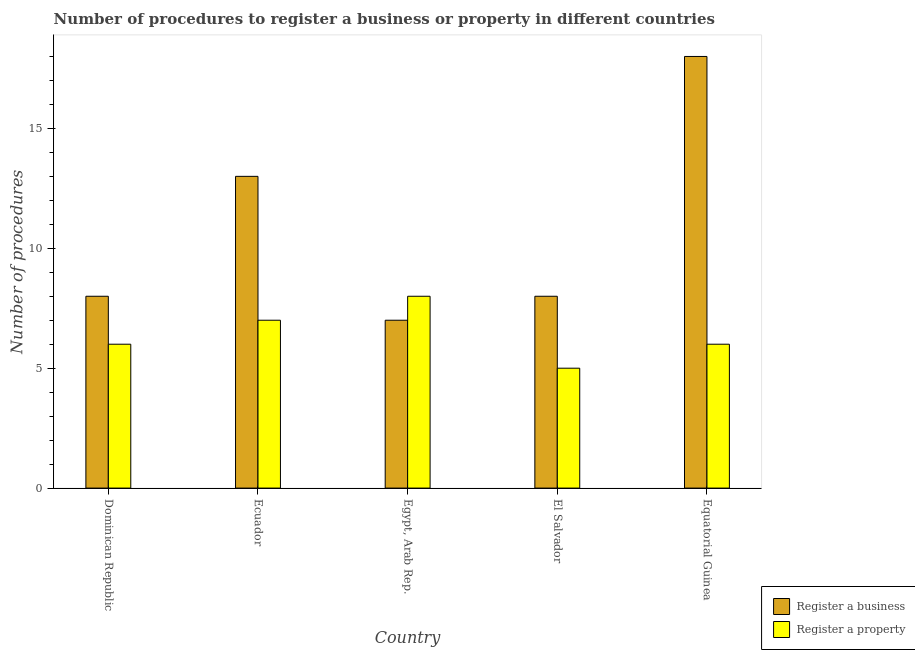How many different coloured bars are there?
Offer a very short reply. 2. How many bars are there on the 4th tick from the left?
Offer a very short reply. 2. What is the label of the 5th group of bars from the left?
Provide a short and direct response. Equatorial Guinea. What is the number of procedures to register a property in Equatorial Guinea?
Provide a short and direct response. 6. In which country was the number of procedures to register a property maximum?
Keep it short and to the point. Egypt, Arab Rep. In which country was the number of procedures to register a business minimum?
Provide a succinct answer. Egypt, Arab Rep. What is the total number of procedures to register a business in the graph?
Provide a succinct answer. 54. What is the difference between the number of procedures to register a business in Dominican Republic and that in Egypt, Arab Rep.?
Offer a very short reply. 1. What is the average number of procedures to register a property per country?
Ensure brevity in your answer.  6.4. What is the difference between the number of procedures to register a property and number of procedures to register a business in Dominican Republic?
Offer a terse response. -2. What is the ratio of the number of procedures to register a business in Dominican Republic to that in Ecuador?
Give a very brief answer. 0.62. Is the difference between the number of procedures to register a property in Dominican Republic and Ecuador greater than the difference between the number of procedures to register a business in Dominican Republic and Ecuador?
Your answer should be compact. Yes. What is the difference between the highest and the lowest number of procedures to register a business?
Your answer should be very brief. 11. Is the sum of the number of procedures to register a business in Dominican Republic and Equatorial Guinea greater than the maximum number of procedures to register a property across all countries?
Provide a succinct answer. Yes. What does the 1st bar from the left in Egypt, Arab Rep. represents?
Your response must be concise. Register a business. What does the 1st bar from the right in Equatorial Guinea represents?
Provide a short and direct response. Register a property. How many bars are there?
Provide a succinct answer. 10. Does the graph contain any zero values?
Provide a succinct answer. No. Does the graph contain grids?
Your answer should be compact. No. How many legend labels are there?
Your answer should be compact. 2. How are the legend labels stacked?
Offer a very short reply. Vertical. What is the title of the graph?
Provide a succinct answer. Number of procedures to register a business or property in different countries. Does "Lower secondary rate" appear as one of the legend labels in the graph?
Keep it short and to the point. No. What is the label or title of the X-axis?
Provide a succinct answer. Country. What is the label or title of the Y-axis?
Ensure brevity in your answer.  Number of procedures. What is the Number of procedures in Register a business in Ecuador?
Your response must be concise. 13. What is the Number of procedures of Register a property in Egypt, Arab Rep.?
Offer a terse response. 8. What is the Number of procedures of Register a business in El Salvador?
Your answer should be very brief. 8. What is the Number of procedures in Register a business in Equatorial Guinea?
Give a very brief answer. 18. What is the Number of procedures in Register a property in Equatorial Guinea?
Offer a very short reply. 6. Across all countries, what is the maximum Number of procedures in Register a business?
Provide a short and direct response. 18. Across all countries, what is the minimum Number of procedures in Register a property?
Your response must be concise. 5. What is the total Number of procedures in Register a business in the graph?
Your answer should be very brief. 54. What is the total Number of procedures in Register a property in the graph?
Keep it short and to the point. 32. What is the difference between the Number of procedures of Register a business in Dominican Republic and that in Ecuador?
Make the answer very short. -5. What is the difference between the Number of procedures of Register a business in Dominican Republic and that in Egypt, Arab Rep.?
Ensure brevity in your answer.  1. What is the difference between the Number of procedures of Register a property in Dominican Republic and that in Egypt, Arab Rep.?
Ensure brevity in your answer.  -2. What is the difference between the Number of procedures of Register a property in Dominican Republic and that in Equatorial Guinea?
Your response must be concise. 0. What is the difference between the Number of procedures of Register a property in Ecuador and that in Egypt, Arab Rep.?
Ensure brevity in your answer.  -1. What is the difference between the Number of procedures in Register a property in Ecuador and that in El Salvador?
Offer a terse response. 2. What is the difference between the Number of procedures of Register a property in Ecuador and that in Equatorial Guinea?
Offer a terse response. 1. What is the difference between the Number of procedures of Register a property in Egypt, Arab Rep. and that in Equatorial Guinea?
Your response must be concise. 2. What is the difference between the Number of procedures in Register a business in Dominican Republic and the Number of procedures in Register a property in Equatorial Guinea?
Keep it short and to the point. 2. What is the difference between the Number of procedures in Register a business in Ecuador and the Number of procedures in Register a property in Egypt, Arab Rep.?
Give a very brief answer. 5. What is the difference between the Number of procedures in Register a business in Ecuador and the Number of procedures in Register a property in El Salvador?
Give a very brief answer. 8. What is the difference between the Number of procedures of Register a business in Ecuador and the Number of procedures of Register a property in Equatorial Guinea?
Give a very brief answer. 7. What is the difference between the Number of procedures of Register a business in Egypt, Arab Rep. and the Number of procedures of Register a property in El Salvador?
Your answer should be very brief. 2. What is the difference between the Number of procedures of Register a business in Egypt, Arab Rep. and the Number of procedures of Register a property in Equatorial Guinea?
Ensure brevity in your answer.  1. What is the difference between the Number of procedures in Register a business in El Salvador and the Number of procedures in Register a property in Equatorial Guinea?
Offer a terse response. 2. What is the average Number of procedures of Register a property per country?
Offer a very short reply. 6.4. What is the difference between the Number of procedures of Register a business and Number of procedures of Register a property in Ecuador?
Your answer should be compact. 6. What is the difference between the Number of procedures of Register a business and Number of procedures of Register a property in Egypt, Arab Rep.?
Offer a terse response. -1. What is the difference between the Number of procedures of Register a business and Number of procedures of Register a property in El Salvador?
Offer a very short reply. 3. What is the ratio of the Number of procedures in Register a business in Dominican Republic to that in Ecuador?
Ensure brevity in your answer.  0.62. What is the ratio of the Number of procedures in Register a property in Dominican Republic to that in Ecuador?
Make the answer very short. 0.86. What is the ratio of the Number of procedures in Register a business in Dominican Republic to that in El Salvador?
Your answer should be compact. 1. What is the ratio of the Number of procedures in Register a property in Dominican Republic to that in El Salvador?
Your answer should be compact. 1.2. What is the ratio of the Number of procedures of Register a business in Dominican Republic to that in Equatorial Guinea?
Make the answer very short. 0.44. What is the ratio of the Number of procedures of Register a property in Dominican Republic to that in Equatorial Guinea?
Offer a terse response. 1. What is the ratio of the Number of procedures in Register a business in Ecuador to that in Egypt, Arab Rep.?
Provide a succinct answer. 1.86. What is the ratio of the Number of procedures of Register a property in Ecuador to that in Egypt, Arab Rep.?
Make the answer very short. 0.88. What is the ratio of the Number of procedures in Register a business in Ecuador to that in El Salvador?
Offer a terse response. 1.62. What is the ratio of the Number of procedures in Register a property in Ecuador to that in El Salvador?
Your answer should be very brief. 1.4. What is the ratio of the Number of procedures of Register a business in Ecuador to that in Equatorial Guinea?
Give a very brief answer. 0.72. What is the ratio of the Number of procedures in Register a business in Egypt, Arab Rep. to that in El Salvador?
Give a very brief answer. 0.88. What is the ratio of the Number of procedures of Register a business in Egypt, Arab Rep. to that in Equatorial Guinea?
Offer a very short reply. 0.39. What is the ratio of the Number of procedures of Register a property in Egypt, Arab Rep. to that in Equatorial Guinea?
Give a very brief answer. 1.33. What is the ratio of the Number of procedures in Register a business in El Salvador to that in Equatorial Guinea?
Your answer should be compact. 0.44. What is the ratio of the Number of procedures in Register a property in El Salvador to that in Equatorial Guinea?
Keep it short and to the point. 0.83. What is the difference between the highest and the second highest Number of procedures in Register a business?
Your response must be concise. 5. What is the difference between the highest and the lowest Number of procedures of Register a business?
Make the answer very short. 11. What is the difference between the highest and the lowest Number of procedures of Register a property?
Provide a succinct answer. 3. 